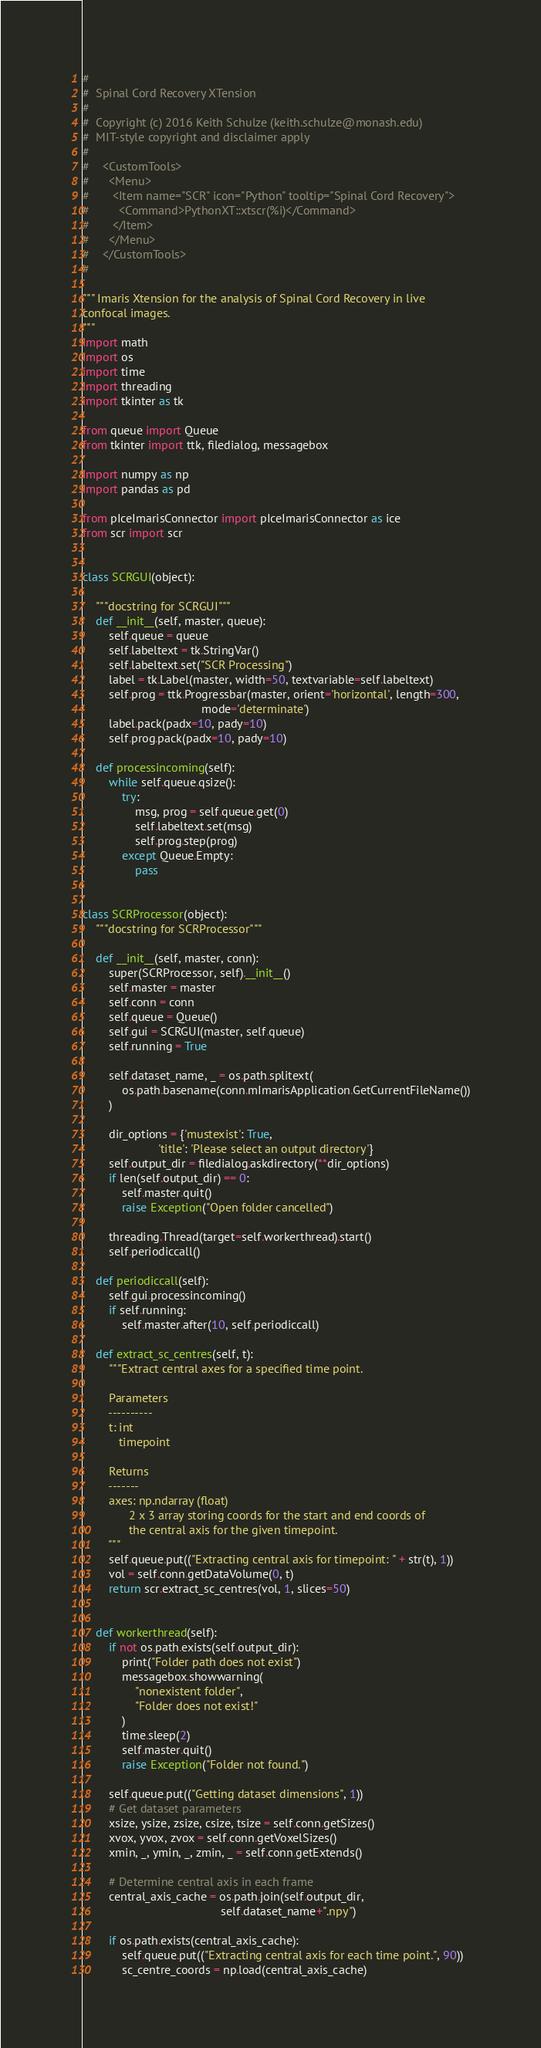<code> <loc_0><loc_0><loc_500><loc_500><_Python_>#
#  Spinal Cord Recovery XTension
#
#  Copyright (c) 2016 Keith Schulze (keith.schulze@monash.edu)
#  MIT-style copyright and disclaimer apply
#
#    <CustomTools>
#      <Menu>
#       <Item name="SCR" icon="Python" tooltip="Spinal Cord Recovery">
#         <Command>PythonXT::xtscr(%i)</Command>
#       </Item>
#      </Menu>
#    </CustomTools>
#

""" Imaris Xtension for the analysis of Spinal Cord Recovery in live
confocal images.
"""
import math
import os
import time
import threading
import tkinter as tk

from queue import Queue
from tkinter import ttk, filedialog, messagebox

import numpy as np
import pandas as pd

from pIceImarisConnector import pIceImarisConnector as ice
from scr import scr


class SCRGUI(object):

    """docstring for SCRGUI"""
    def __init__(self, master, queue):
        self.queue = queue
        self.labeltext = tk.StringVar()
        self.labeltext.set("SCR Processing")
        label = tk.Label(master, width=50, textvariable=self.labeltext)
        self.prog = ttk.Progressbar(master, orient='horizontal', length=300,
                                    mode='determinate')
        label.pack(padx=10, pady=10)
        self.prog.pack(padx=10, pady=10)

    def processincoming(self):
        while self.queue.qsize():
            try:
                msg, prog = self.queue.get(0)
                self.labeltext.set(msg)
                self.prog.step(prog)
            except Queue.Empty:
                pass


class SCRProcessor(object):
    """docstring for SCRProcessor"""

    def __init__(self, master, conn):
        super(SCRProcessor, self).__init__()
        self.master = master
        self.conn = conn
        self.queue = Queue()
        self.gui = SCRGUI(master, self.queue)
        self.running = True

        self.dataset_name, _ = os.path.splitext(
            os.path.basename(conn.mImarisApplication.GetCurrentFileName())
        )

        dir_options = {'mustexist': True,
                       'title': 'Please select an output directory'}
        self.output_dir = filedialog.askdirectory(**dir_options)
        if len(self.output_dir) == 0:
            self.master.quit()
            raise Exception("Open folder cancelled")

        threading.Thread(target=self.workerthread).start()
        self.periodiccall()

    def periodiccall(self):
        self.gui.processincoming()
        if self.running:
            self.master.after(10, self.periodiccall)

    def extract_sc_centres(self, t):
        """Extract central axes for a specified time point.

        Parameters
        ----------
        t: int
           timepoint

        Returns
        -------
        axes: np.ndarray (float)
              2 x 3 array storing coords for the start and end coords of
              the central axis for the given timepoint.
        """
        self.queue.put(("Extracting central axis for timepoint: " + str(t), 1))
        vol = self.conn.getDataVolume(0, t)
        return scr.extract_sc_centres(vol, 1, slices=50)


    def workerthread(self):
        if not os.path.exists(self.output_dir):
            print("Folder path does not exist")
            messagebox.showwarning(
                "nonexistent folder",
                "Folder does not exist!"
            )
            time.sleep(2)
            self.master.quit()
            raise Exception("Folder not found.")

        self.queue.put(("Getting dataset dimensions", 1))
        # Get dataset parameters
        xsize, ysize, zsize, csize, tsize = self.conn.getSizes()
        xvox, yvox, zvox = self.conn.getVoxelSizes()
        xmin, _, ymin, _, zmin, _ = self.conn.getExtends()

        # Determine central axis in each frame
        central_axis_cache = os.path.join(self.output_dir,
                                          self.dataset_name+".npy")

        if os.path.exists(central_axis_cache):
            self.queue.put(("Extracting central axis for each time point.", 90))
            sc_centre_coords = np.load(central_axis_cache)</code> 